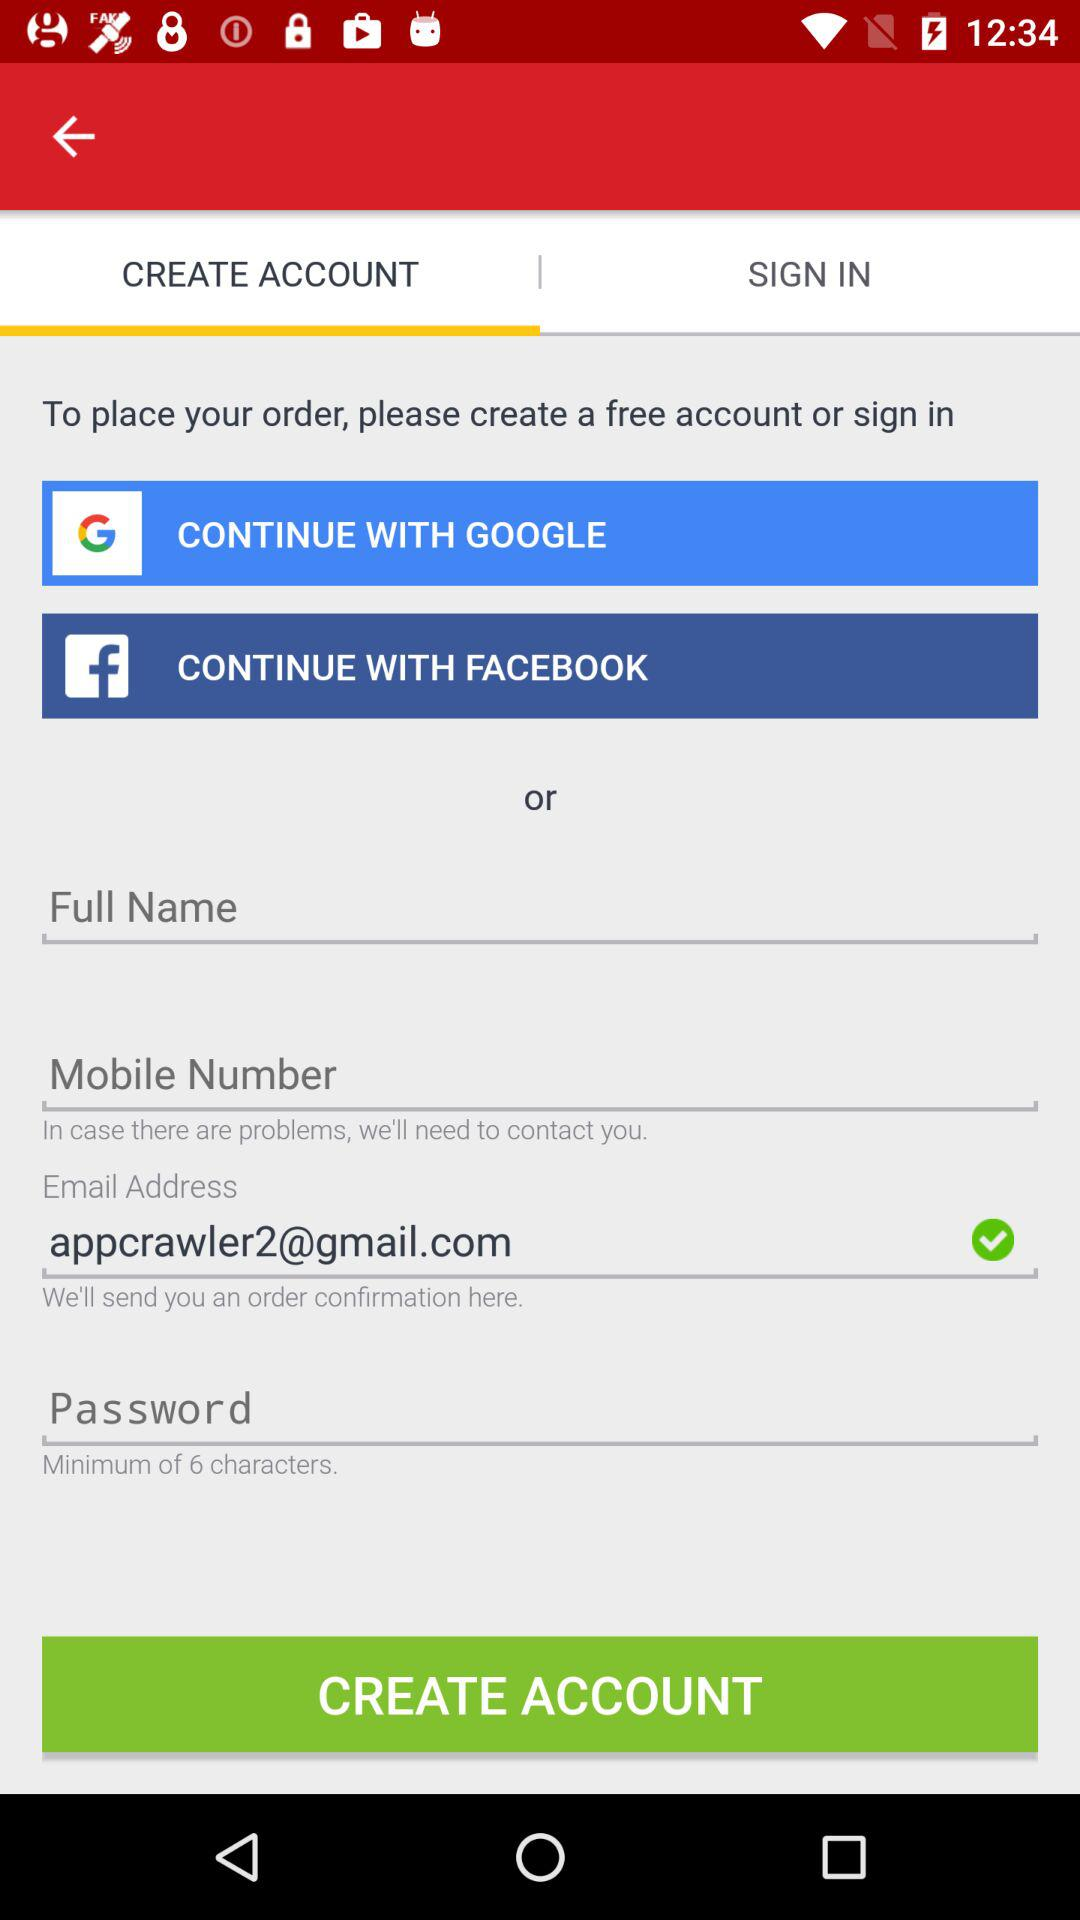On which tab am I? You are on the "CREATE ACCOUNT" tab. 